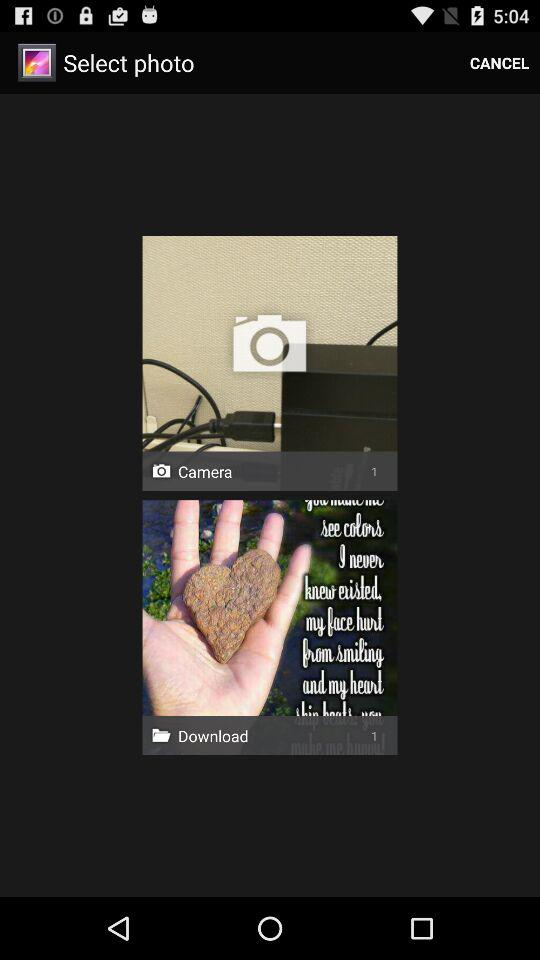How many photos are there in the folder named "Download"? There is 1 photo. 